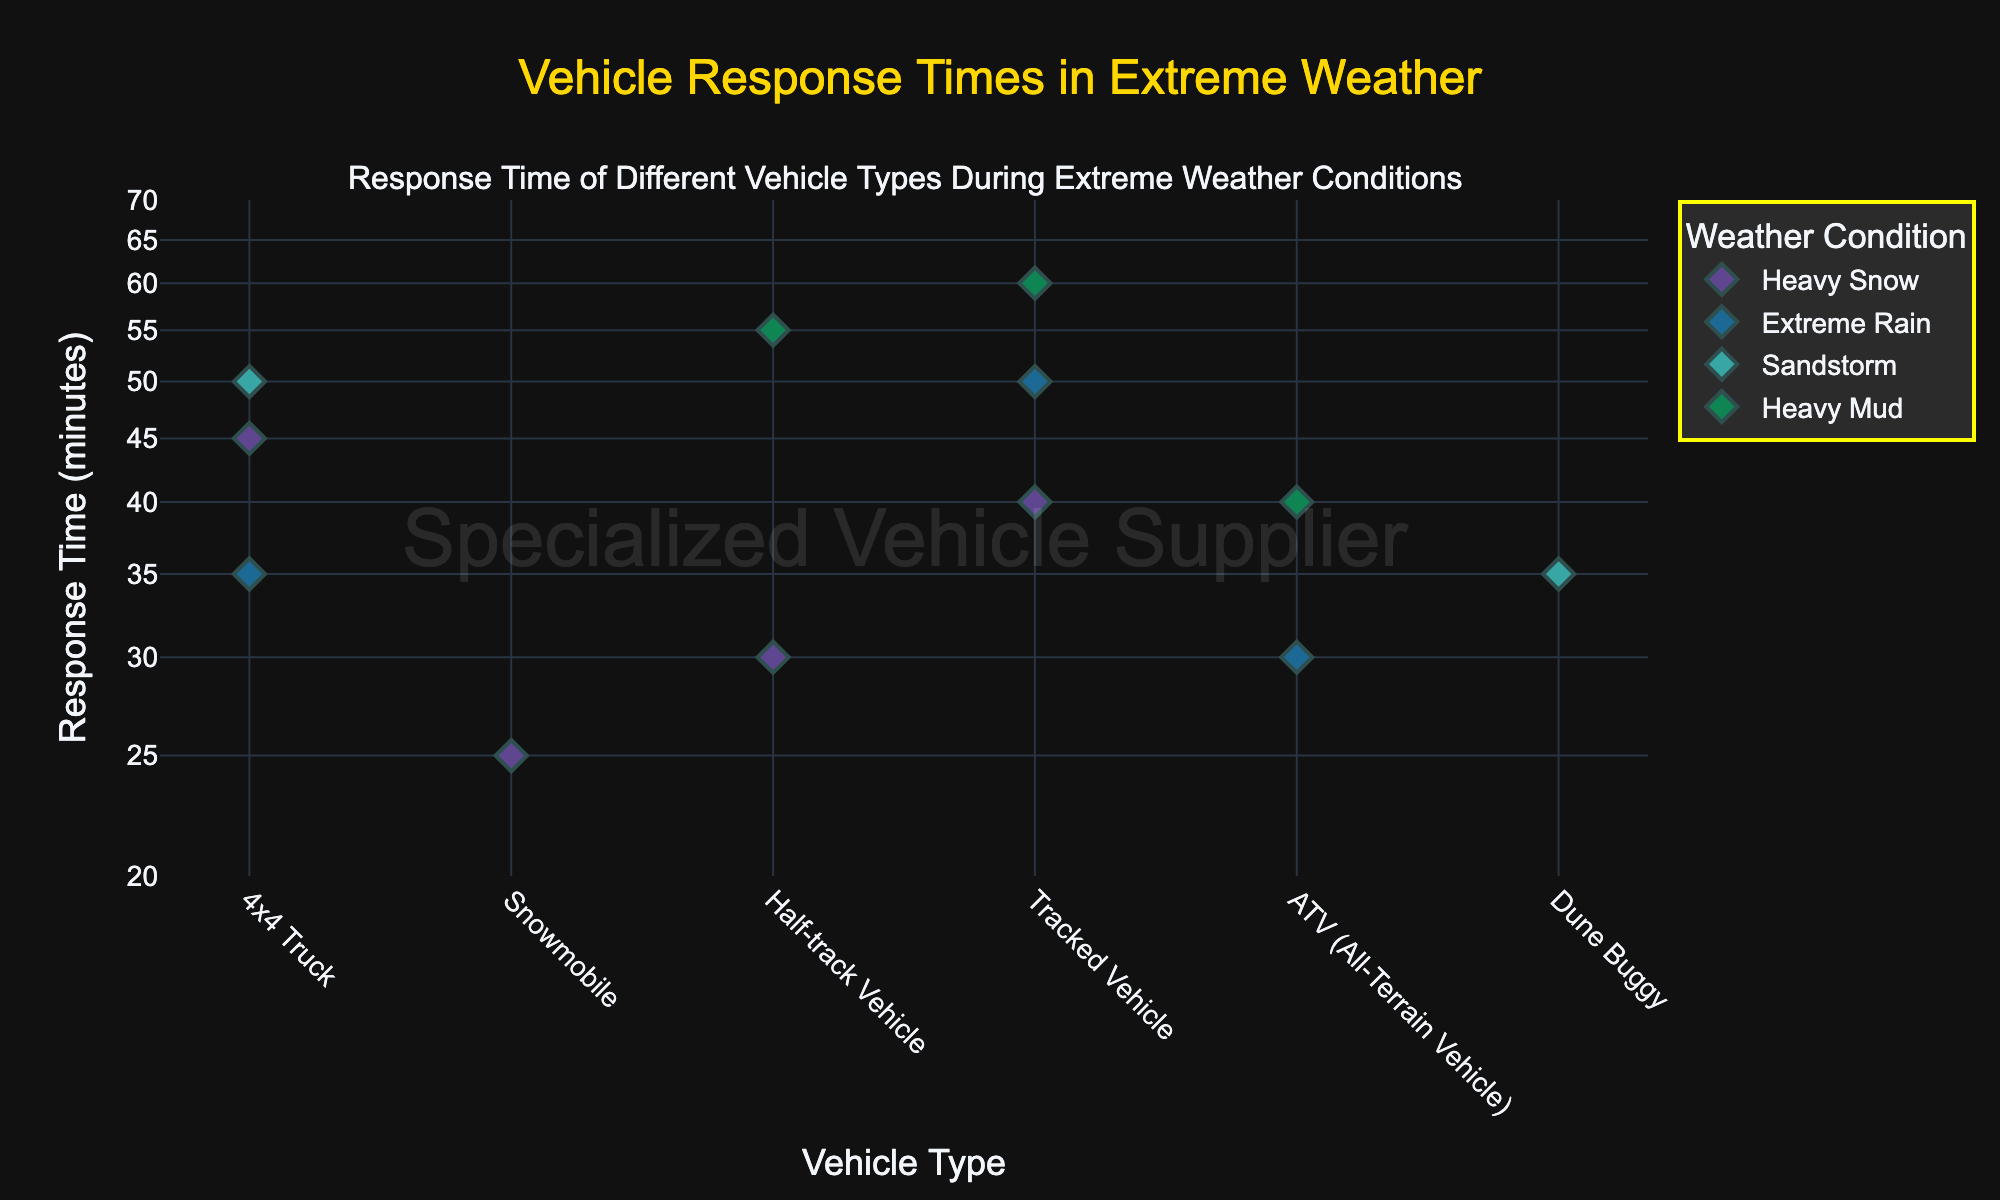What is the title of the plot? The title is displayed at the top of the figure in large font. It reads "Vehicle Response Times in Extreme Weather".
Answer: Vehicle Response Times in Extreme Weather Which vehicle type has the longest response time in heavy snow? Look for the markers corresponding to heavy snow, find the one with the highest value on the y-axis. The tracked vehicle has a response time of 40 minutes in heavy snow.
Answer: Tracked Vehicle What is the response time of an ATV in extreme rain? Locate the marker for the ATV vehicle type, then find the data point corresponding to extreme rain. The y-value of this point is the response time.
Answer: 30 How many different weather conditions are displayed in the plot? Count the unique legend labels. There are four legends representing different weather conditions: Heavy Snow, Extreme Rain, Sandstorm, Heavy Mud.
Answer: 4 Which vehicle type has the shortest response time in extreme rain? Compare the response times of all vehicle types in the extreme rain category. The 4x4 Truck has a response time of 35 minutes in extreme rain.
Answer: 4x4 Truck What is the average response time for all vehicle types during heavy snow? List the response times for each vehicle type during heavy snow (45, 25, 30, and 40). Sum these values (45 + 25 + 30 + 40 = 140), then divide by the number of data points (140/4 = 35).
Answer: 35 Which vehicle type has the largest difference in response times between heavy mud and extreme rain? Calculate the difference for each vehicle type that appears in both categories. For the Tracked Vehicle, the response times are 60 (heavy mud) and 50 (extreme rain), so the difference is 10 minutes. Compare this with the ATV's difference (10 minutes) - both have the greatest difference of 10 minutes.
Answer: Tracked Vehicle, ATV What is the response time range for the 4x4 Truck across all weather conditions? Identify the response times for all weather conditions (45, 35, 50). Find the minimum (35) and maximum (50) response times.
Answer: 35 to 50 Which vehicle type has consistently high response times (above 50 minutes) in multiple conditions? Identify vehicle types that have response times above 50 minutes. The Tracked Vehicle has high response times in heavy mud (60 minutes) but no other consistent high values above 50 minutes for multiple conditions.
Answer: None 